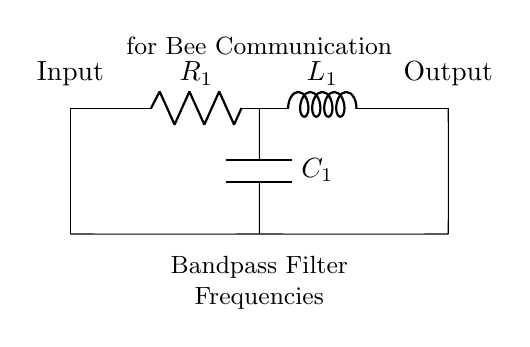What type of filter is represented in this circuit? The circuit diagram indicates that it is a bandpass filter, which is designed to allow a specific range of frequencies to pass while attenuating others. This is indicated by the labeling in the diagram.
Answer: Bandpass filter What are the components used in the circuit? The circuit contains three main components: a resistor, an inductor, and a capacitor. These components are labeled as R1, L1, and C1 respectively on the diagram.
Answer: Resistor, inductor, capacitor What is the connection form of the circuit? The circuit is connected in a series configuration with the resistor, inductor, and a parallel connection between the capacitor and the resistor creating the desired filtering effect. The diagram shows clear connections between the components.
Answer: Series and parallel What frequency range could this filter detect? While the exact frequency range is not specified in the circuit diagram, bandpass filters typically target a specific frequency range which could be derived from the values of the components used.
Answer: Specific range (needs calculations) Why is a bandpass filter suitable for bee communication? A bandpass filter allows specific frequencies relevant to bee communication to be detected, filtering out unwanted signals and noise. It enhances the clarity of the communication frequencies from the bees.
Answer: Enhances communication frequencies What is the role of the capacitor in this circuit? The capacitor in this circuit serves to store and release electrical energy, which helps in shaping the filter's frequency response and providing phase shift, essential for achieving the desired bandpass effect.
Answer: Store and release energy What could happen if the resistor value is increased in this circuit? Increasing the resistance would decrease the overall current flowing through the circuit, which could lead to lower output signals and potentially affect the filter’s performance negatively, inhibiting its ability to detect bee communication frequencies effectively.
Answer: Lower output signals 